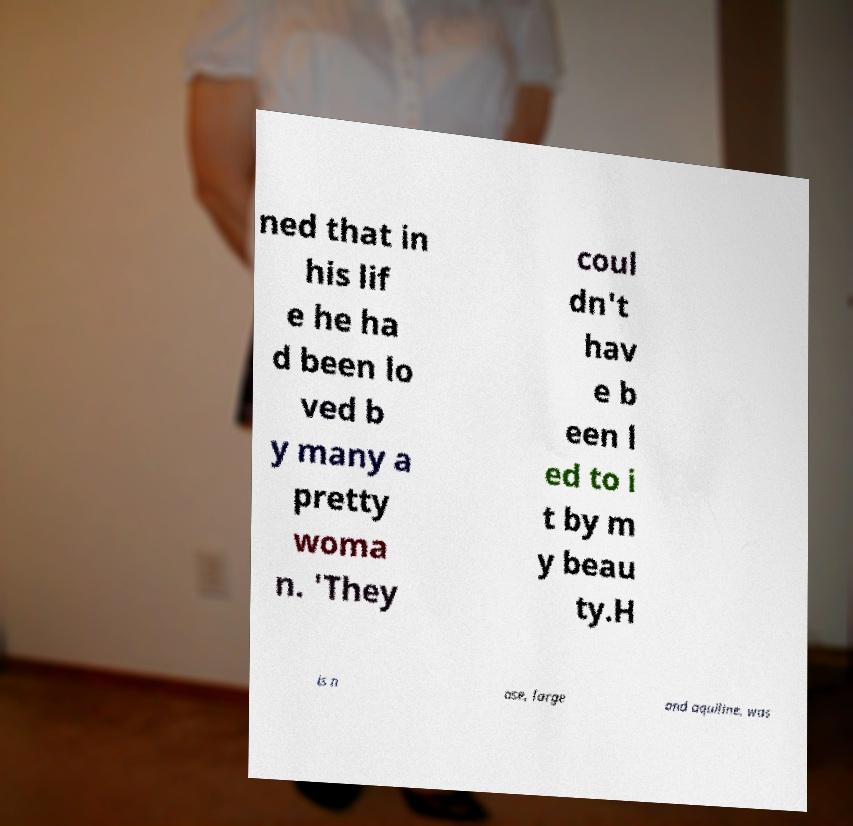Could you extract and type out the text from this image? ned that in his lif e he ha d been lo ved b y many a pretty woma n. 'They coul dn't hav e b een l ed to i t by m y beau ty.H is n ose, large and aquiline, was 